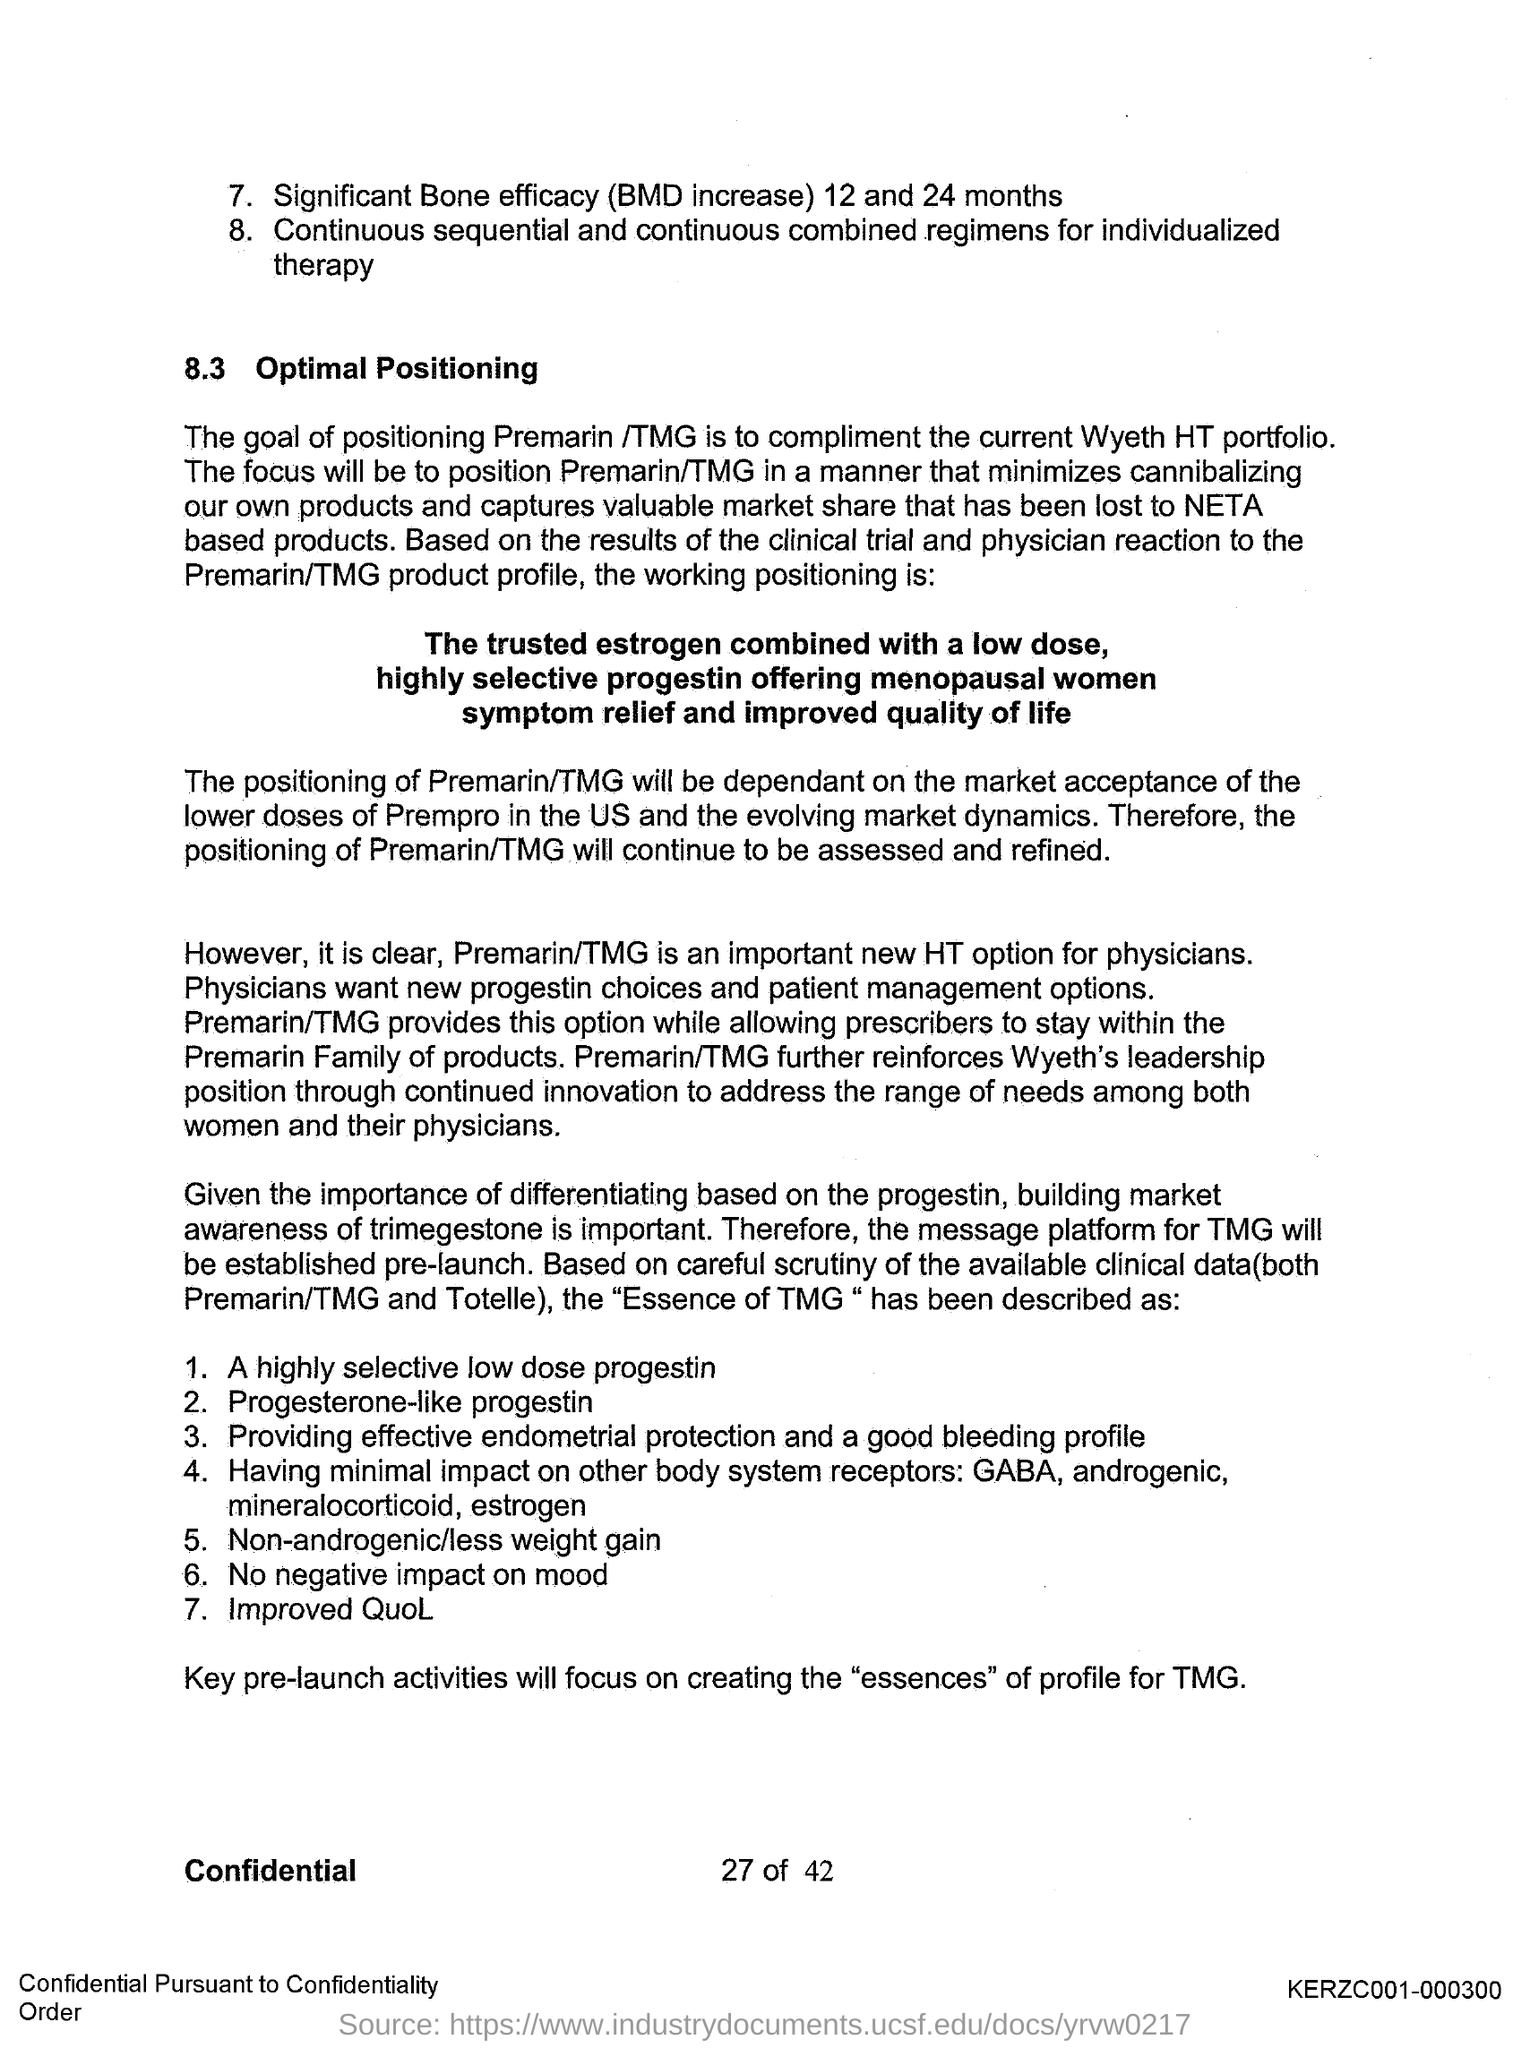List a handful of essential elements in this visual. The first title in the document is '8.3 Optimal Positioning.' 